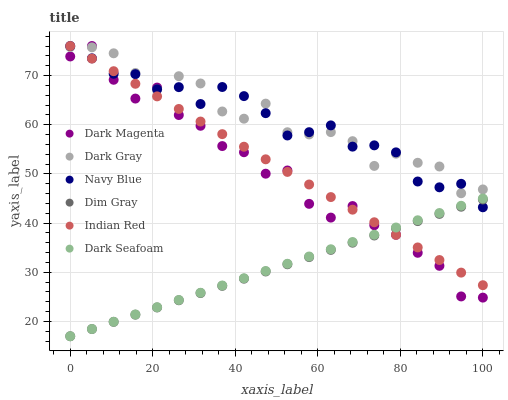Does Dim Gray have the minimum area under the curve?
Answer yes or no. Yes. Does Dark Gray have the maximum area under the curve?
Answer yes or no. Yes. Does Dark Magenta have the minimum area under the curve?
Answer yes or no. No. Does Dark Magenta have the maximum area under the curve?
Answer yes or no. No. Is Dim Gray the smoothest?
Answer yes or no. Yes. Is Dark Magenta the roughest?
Answer yes or no. Yes. Is Navy Blue the smoothest?
Answer yes or no. No. Is Navy Blue the roughest?
Answer yes or no. No. Does Dim Gray have the lowest value?
Answer yes or no. Yes. Does Dark Magenta have the lowest value?
Answer yes or no. No. Does Indian Red have the highest value?
Answer yes or no. Yes. Does Dark Gray have the highest value?
Answer yes or no. No. Is Dark Seafoam less than Dark Gray?
Answer yes or no. Yes. Is Dark Gray greater than Dark Seafoam?
Answer yes or no. Yes. Does Indian Red intersect Dark Magenta?
Answer yes or no. Yes. Is Indian Red less than Dark Magenta?
Answer yes or no. No. Is Indian Red greater than Dark Magenta?
Answer yes or no. No. Does Dark Seafoam intersect Dark Gray?
Answer yes or no. No. 